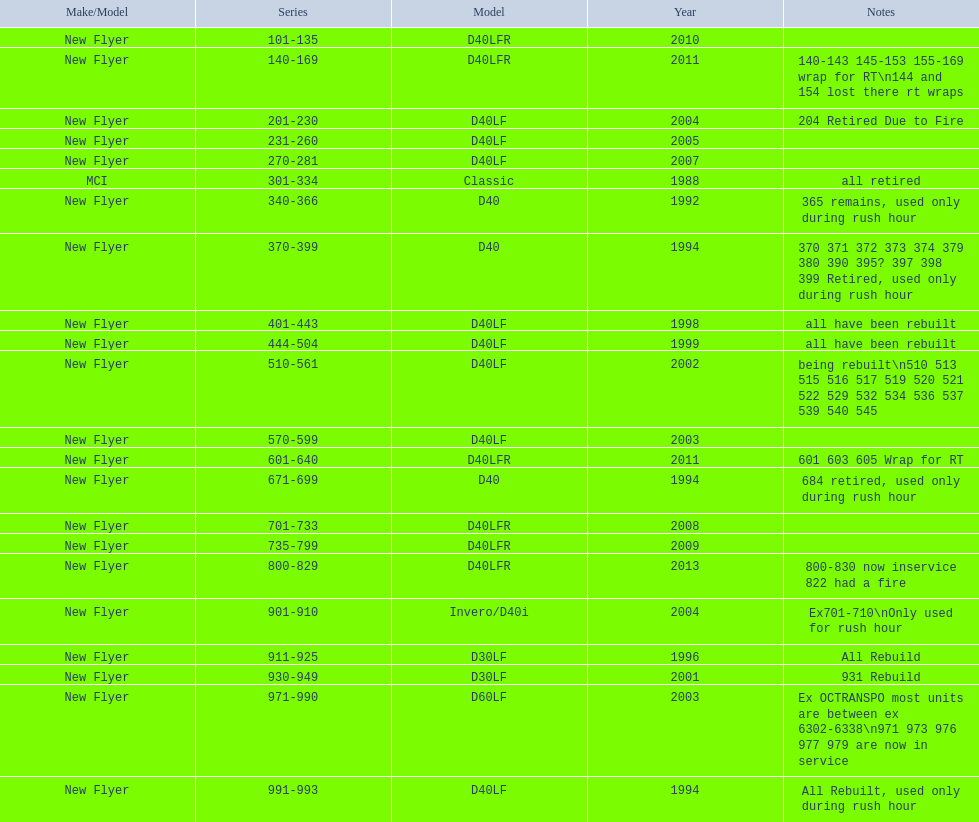What are the entire bus series numbers? 101-135, 140-169, 201-230, 231-260, 270-281, 301-334, 340-366, 370-399, 401-443, 444-504, 510-561, 570-599, 601-640, 671-699, 701-733, 735-799, 800-829, 901-910, 911-925, 930-949, 971-990, 991-993. When were they launched? 2010, 2011, 2004, 2005, 2007, 1988, 1992, 1994, 1998, 1999, 2002, 2003, 2011, 1994, 2008, 2009, 2013, 2004, 1996, 2001, 2003, 1994. Which series is the latest? 800-829. 